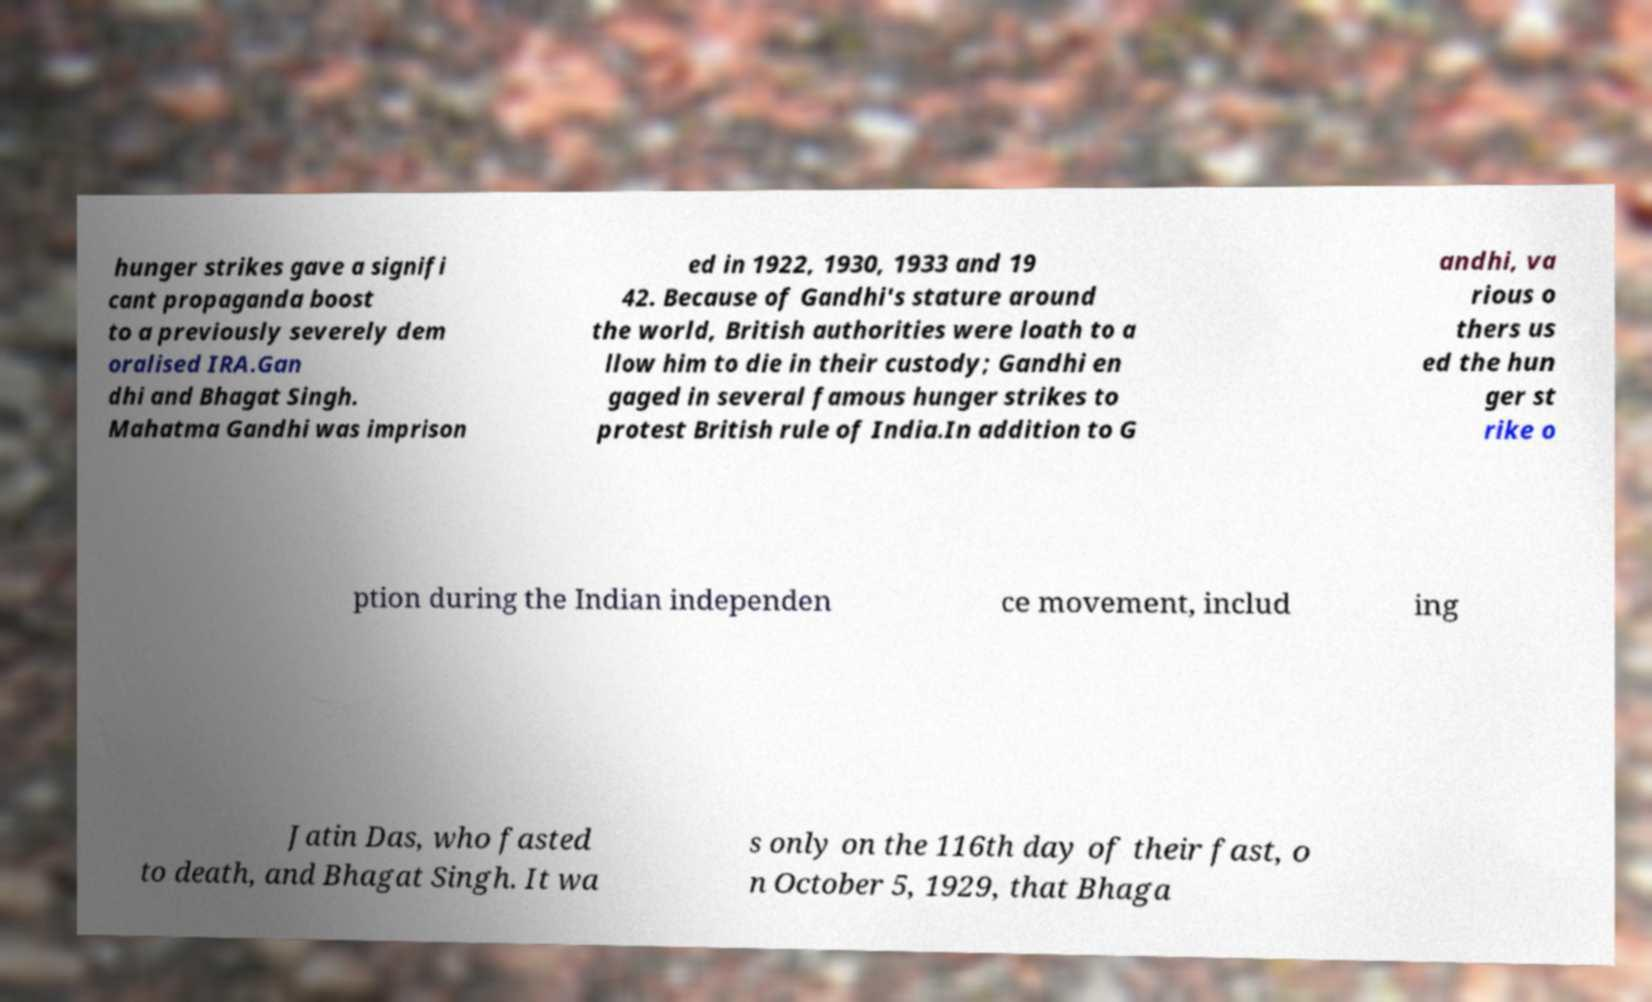What messages or text are displayed in this image? I need them in a readable, typed format. hunger strikes gave a signifi cant propaganda boost to a previously severely dem oralised IRA.Gan dhi and Bhagat Singh. Mahatma Gandhi was imprison ed in 1922, 1930, 1933 and 19 42. Because of Gandhi's stature around the world, British authorities were loath to a llow him to die in their custody; Gandhi en gaged in several famous hunger strikes to protest British rule of India.In addition to G andhi, va rious o thers us ed the hun ger st rike o ption during the Indian independen ce movement, includ ing Jatin Das, who fasted to death, and Bhagat Singh. It wa s only on the 116th day of their fast, o n October 5, 1929, that Bhaga 